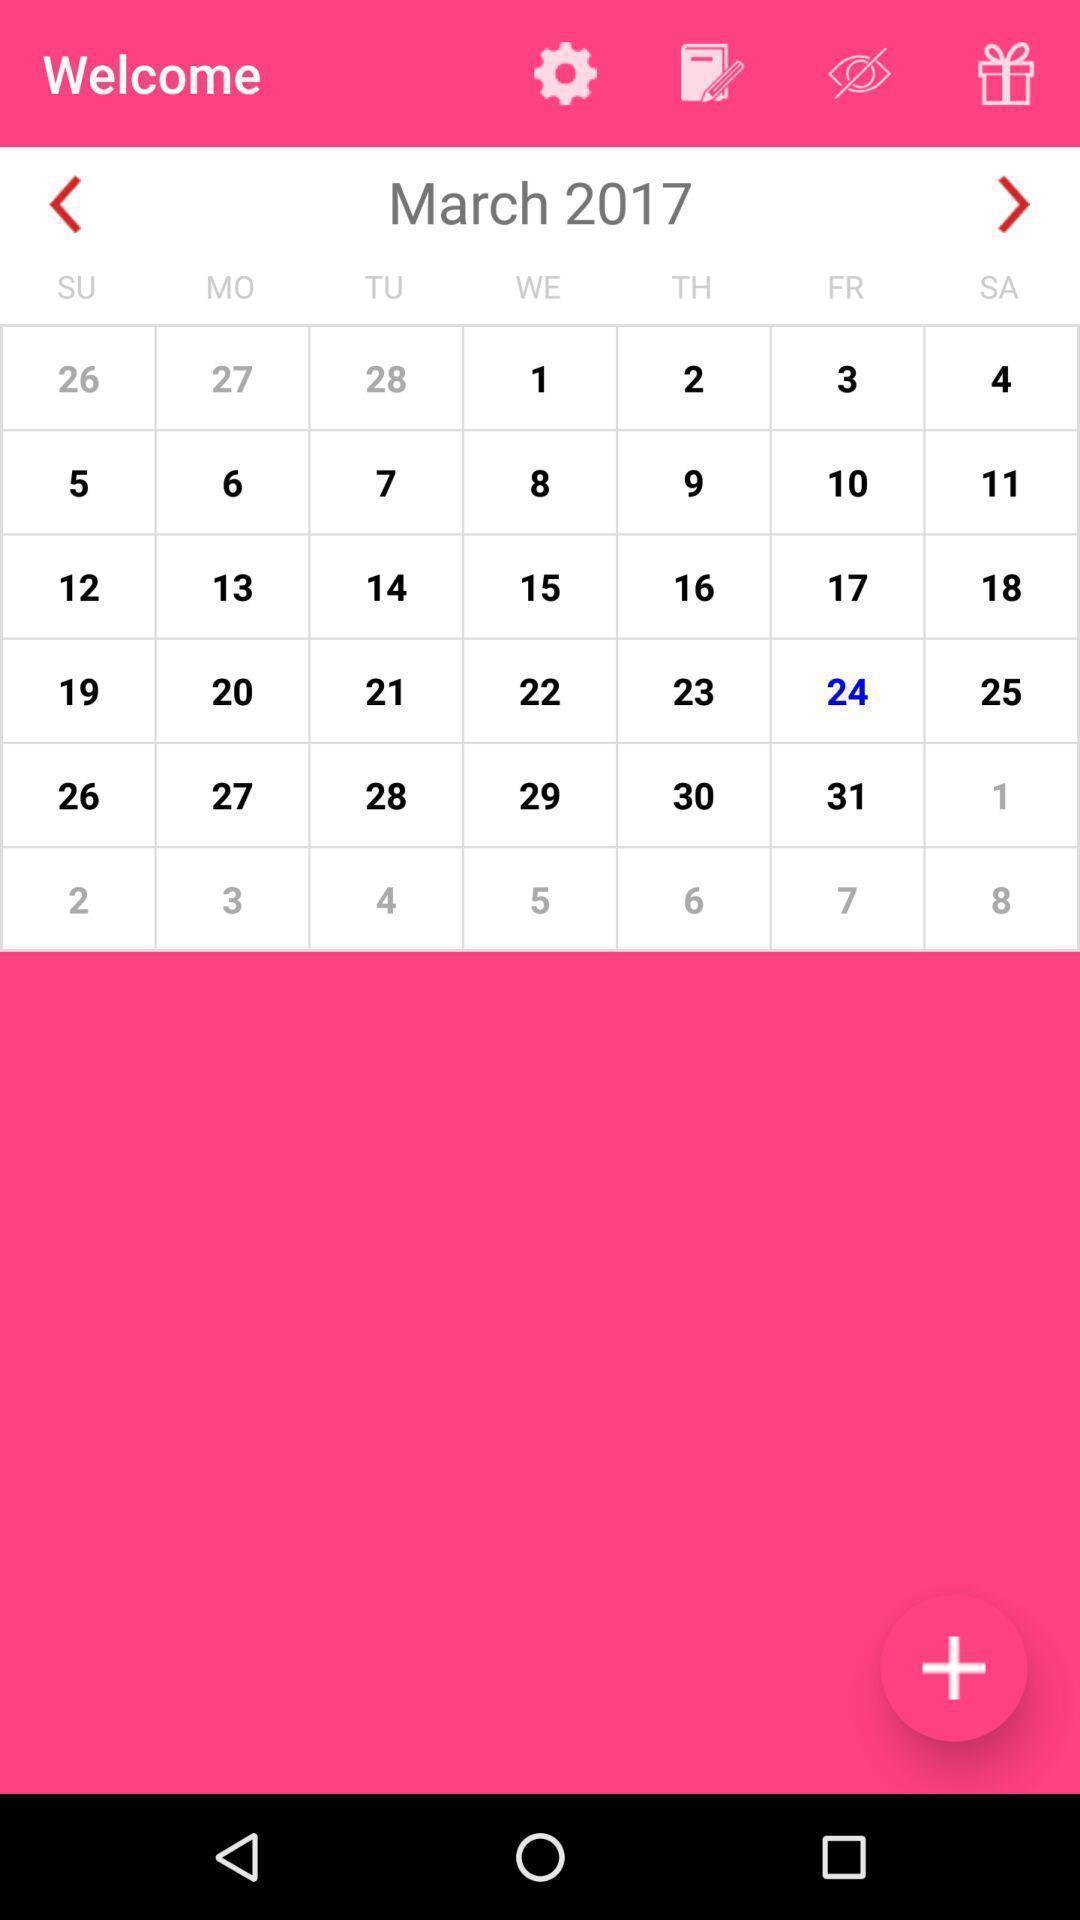Please provide a description for this image. Page showing a calendar on a dairy app. 